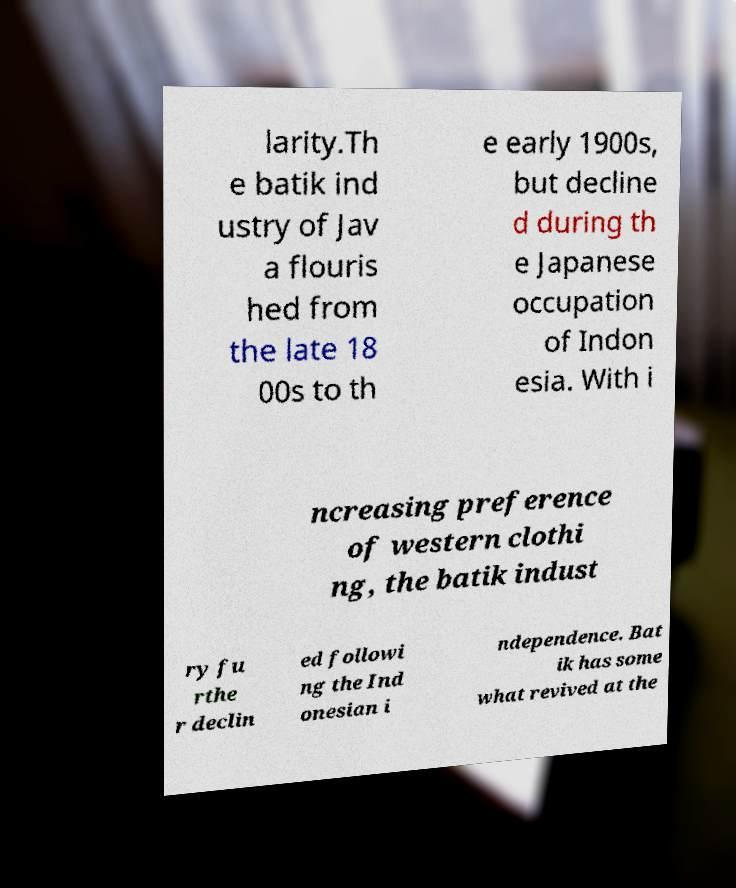There's text embedded in this image that I need extracted. Can you transcribe it verbatim? larity.Th e batik ind ustry of Jav a flouris hed from the late 18 00s to th e early 1900s, but decline d during th e Japanese occupation of Indon esia. With i ncreasing preference of western clothi ng, the batik indust ry fu rthe r declin ed followi ng the Ind onesian i ndependence. Bat ik has some what revived at the 